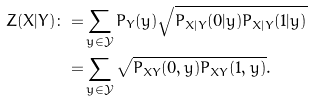Convert formula to latex. <formula><loc_0><loc_0><loc_500><loc_500>Z ( X | Y ) \colon = & \sum _ { y \in \mathcal { Y } } P _ { Y } ( y ) \sqrt { P _ { X | Y } ( 0 | y ) P _ { X | Y } ( 1 | y ) } \\ = & \sum _ { y \in \mathcal { Y } } \sqrt { P _ { X Y } ( 0 , y ) P _ { X Y } ( 1 , y ) } .</formula> 